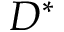<formula> <loc_0><loc_0><loc_500><loc_500>D ^ { * }</formula> 